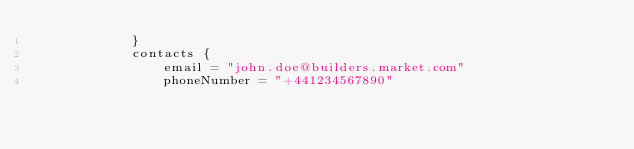Convert code to text. <code><loc_0><loc_0><loc_500><loc_500><_Kotlin_>            }
            contacts {
                email = "john.doe@builders.market.com"
                phoneNumber = "+441234567890"</code> 